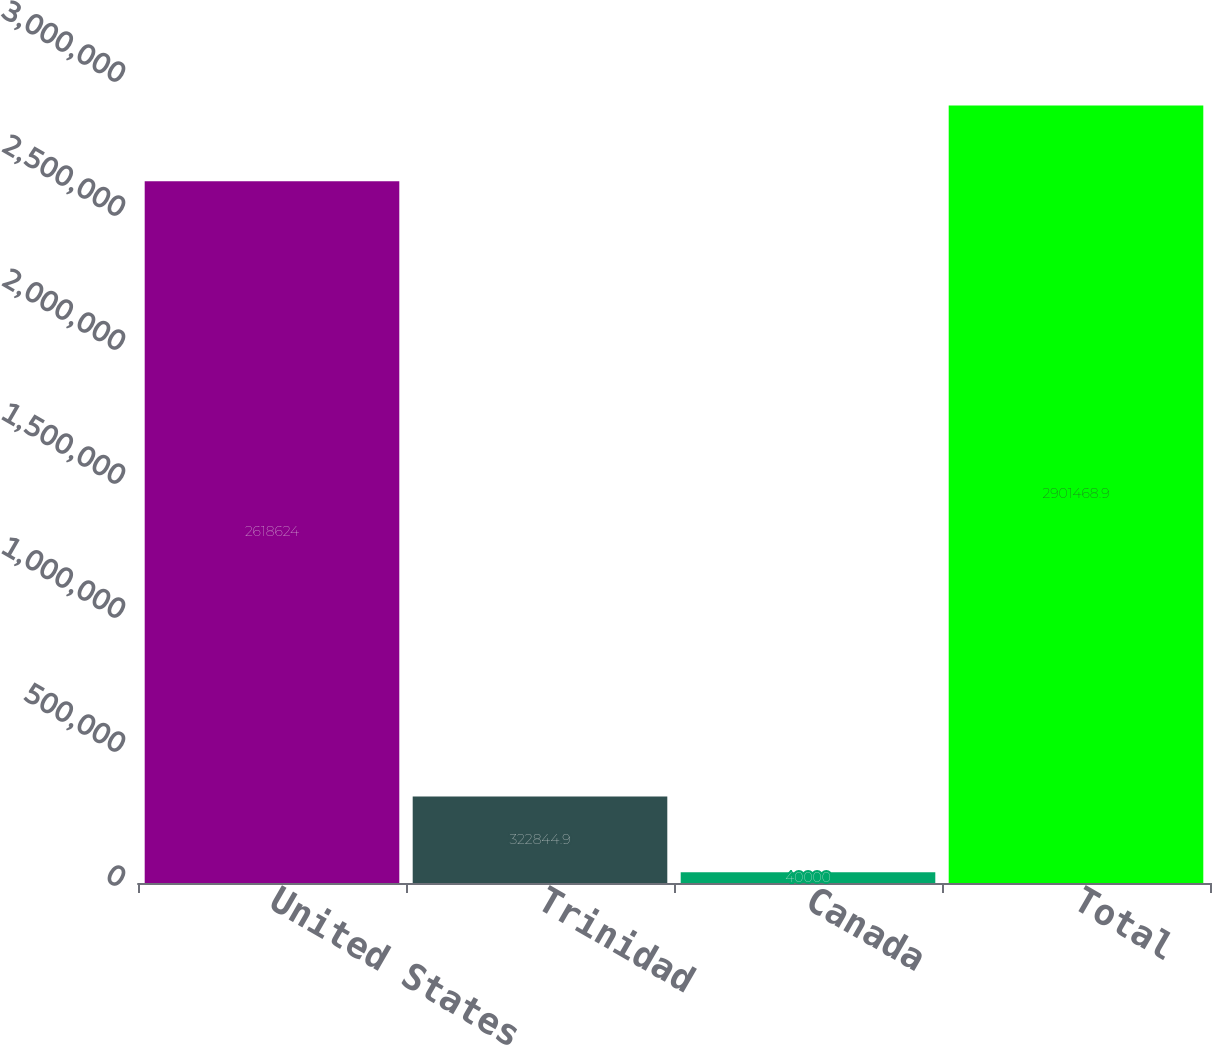<chart> <loc_0><loc_0><loc_500><loc_500><bar_chart><fcel>United States<fcel>Trinidad<fcel>Canada<fcel>Total<nl><fcel>2.61862e+06<fcel>322845<fcel>40000<fcel>2.90147e+06<nl></chart> 